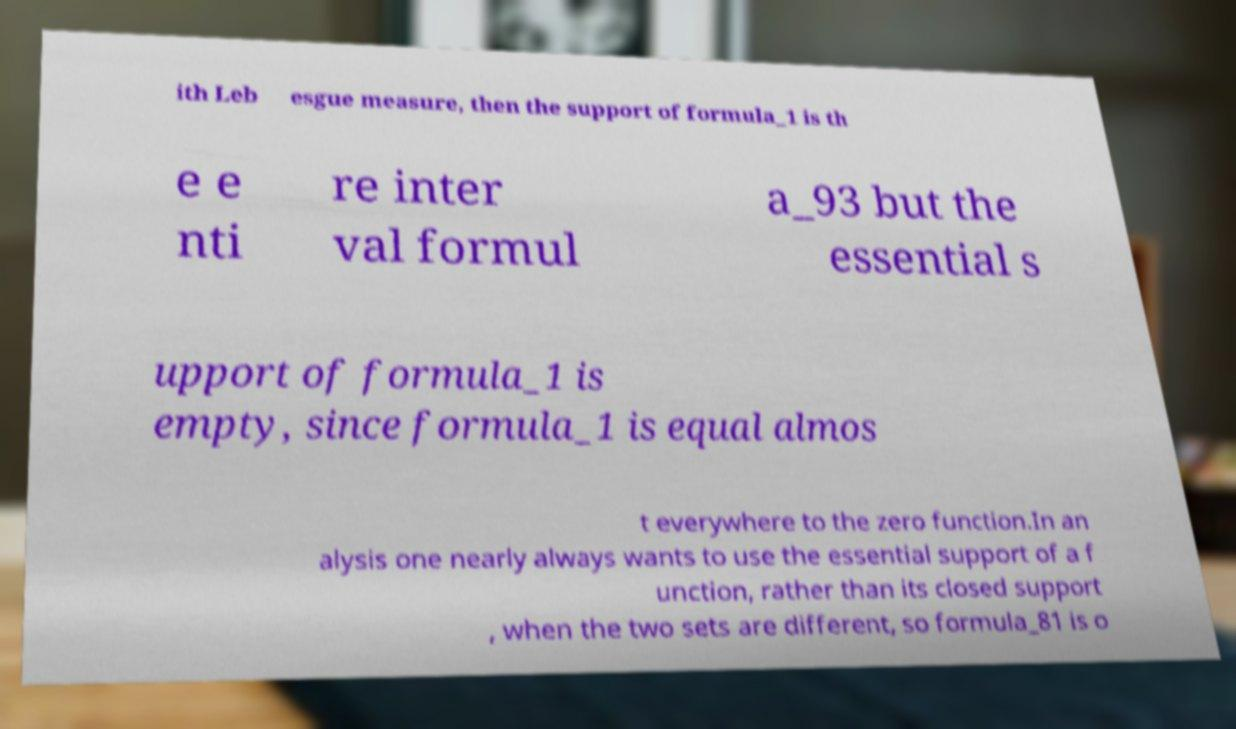Please identify and transcribe the text found in this image. ith Leb esgue measure, then the support of formula_1 is th e e nti re inter val formul a_93 but the essential s upport of formula_1 is empty, since formula_1 is equal almos t everywhere to the zero function.In an alysis one nearly always wants to use the essential support of a f unction, rather than its closed support , when the two sets are different, so formula_81 is o 